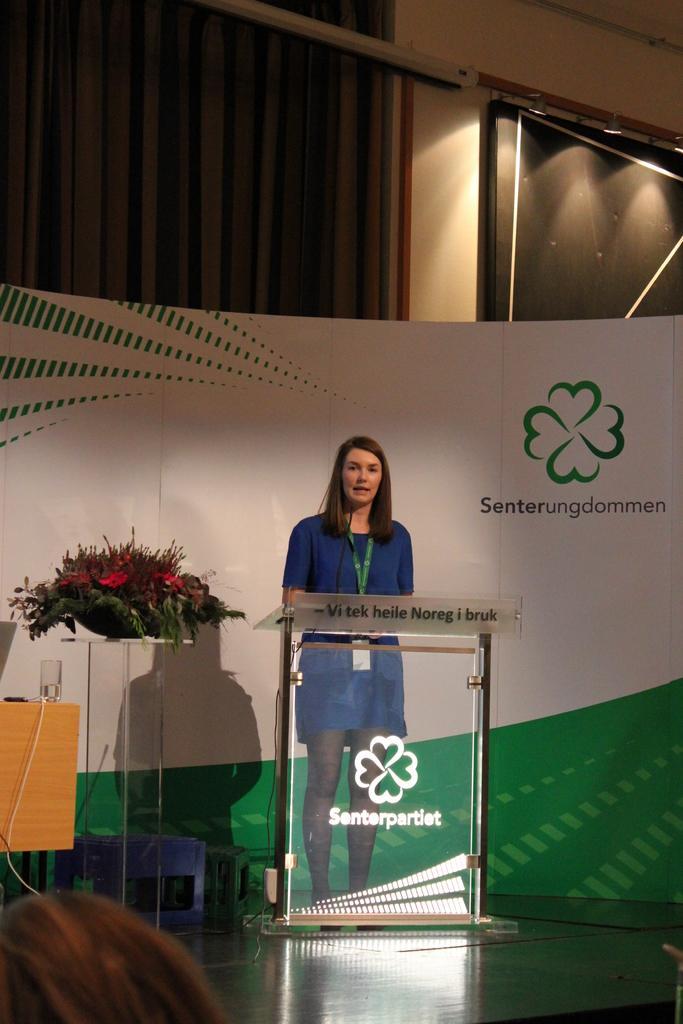Please provide a concise description of this image. In this image we can see a person standing near the podium, there is a mic to the podium, there is a flower bouquet on the table, there is a banner with text behind the person and there are few objects on the stage and there is a curtain to the wall in the background. 